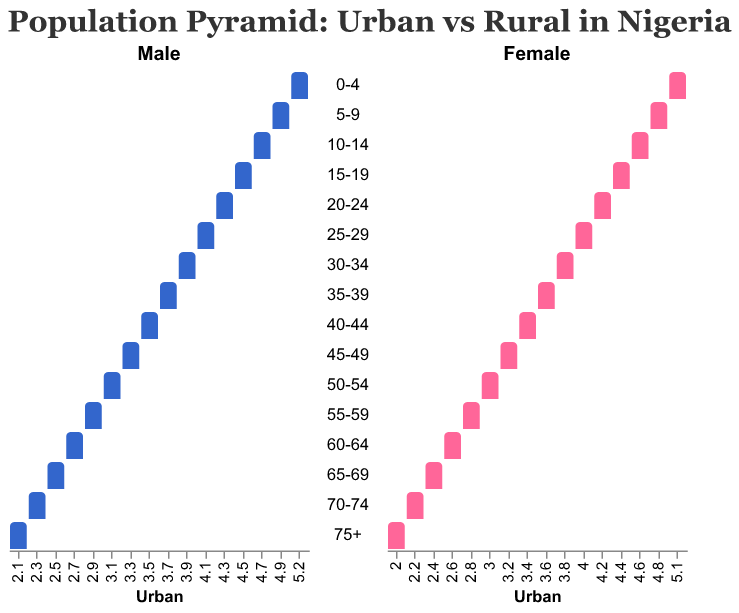What is the title of the figure? The title is displayed at the top of the figure, indicating its main purpose. It reads "Population Pyramid: Urban vs Rural in Nigeria".
Answer: Population Pyramid: Urban vs Rural in Nigeria What are the two categories compared in the Population Pyramid? The figure compares "Urban" and "Rural" populations in Nigeria, seen through distinct subcategories for males and females across different age groups.
Answer: Urban and Rural What age group has the highest percentage of urban male population? By looking at the Urban Male bars, the age group "0-4" shows the highest percentage with 5.2%.
Answer: 0-4 Which age group shows the smallest difference between urban and rural populations for females? By comparing the percentages, age group "75+" shows the smallest difference between Urban Female (2.0%) and Rural Female (2.1%), a difference of 0.1%.
Answer: 75+ For age group 20-24, how do urban males compare with rural males? Urban males in the age group 20-24 have a percentage of 4.3%, whereas rural males have 5.6%, indicating rural males are higher by 1.3%.
Answer: Rural males are higher What is the percentage difference of urban and rural females in the 10-14 age group? Urban females are 4.6% while rural females are 6.0%. The difference is 6.0% - 4.6% = 1.4%.
Answer: 1.4% In the 30-34 age group, are there more urban or rural females? Urban females are at 3.8%, while rural females are at 4.8%, so there are more rural females.
Answer: Rural females Which gender has a higher population percentage in urban areas for age group 55-59? Urban males have a percentage of 2.9%, while urban females have 2.8%, making urban males slightly higher.
Answer: Urban males Does the population percentage decrease more rapidly with age in urban or rural areas? By observing the figure, the percentage decreases more rapidly with age in urban areas compared to rural areas.
Answer: Urban areas What observation can be made about the overall comparison of young populations (0-19 years) between urban and rural areas? The bars for the 0-19 age groups (0-4, 5-9, 10-14, 15-19) are consistently longer for rural populations compared to urban, indicating a significantly larger young population in rural areas.
Answer: Larger young population in rural areas 